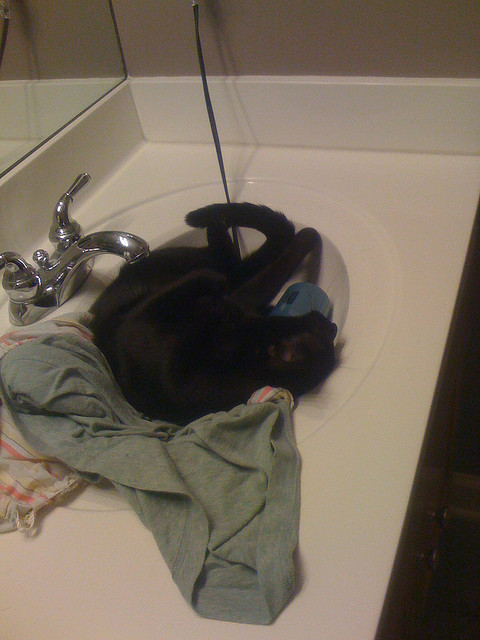What type of animal is resting in the sink? The animal resting in the sink is a cat. 